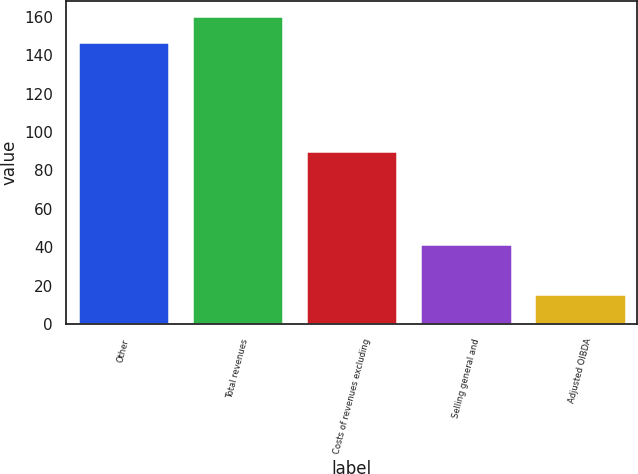Convert chart to OTSL. <chart><loc_0><loc_0><loc_500><loc_500><bar_chart><fcel>Other<fcel>Total revenues<fcel>Costs of revenues excluding<fcel>Selling general and<fcel>Adjusted OIBDA<nl><fcel>147<fcel>160.2<fcel>90<fcel>42<fcel>16<nl></chart> 